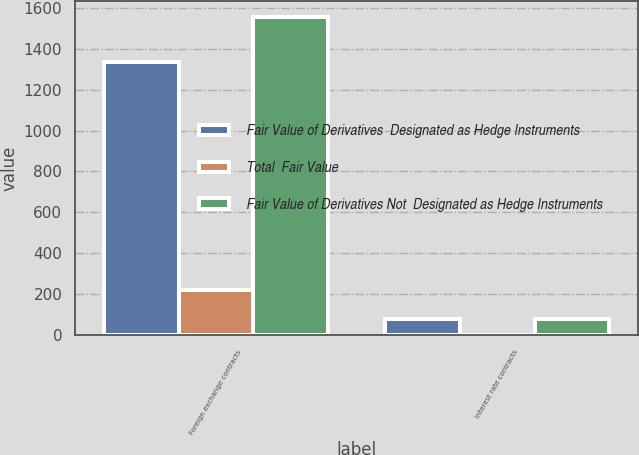Convert chart. <chart><loc_0><loc_0><loc_500><loc_500><stacked_bar_chart><ecel><fcel>Foreign exchange contracts<fcel>Interest rate contracts<nl><fcel>Fair Value of Derivatives  Designated as Hedge Instruments<fcel>1332<fcel>81<nl><fcel>Total  Fair Value<fcel>222<fcel>0<nl><fcel>Fair Value of Derivatives Not  Designated as Hedge Instruments<fcel>1554<fcel>81<nl></chart> 